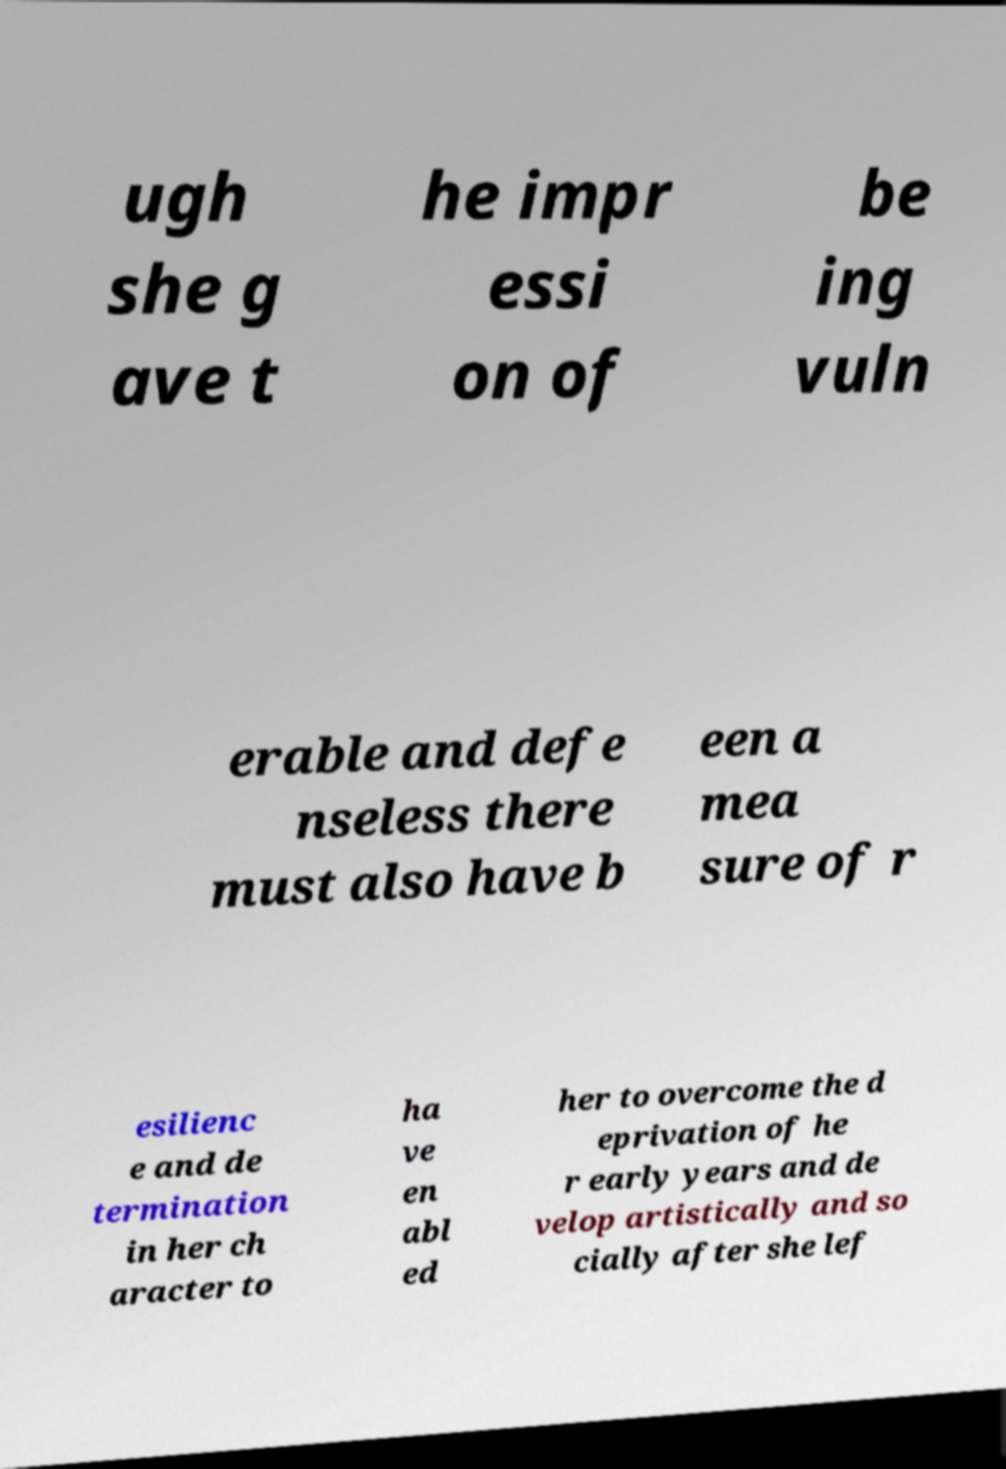There's text embedded in this image that I need extracted. Can you transcribe it verbatim? ugh she g ave t he impr essi on of be ing vuln erable and defe nseless there must also have b een a mea sure of r esilienc e and de termination in her ch aracter to ha ve en abl ed her to overcome the d eprivation of he r early years and de velop artistically and so cially after she lef 